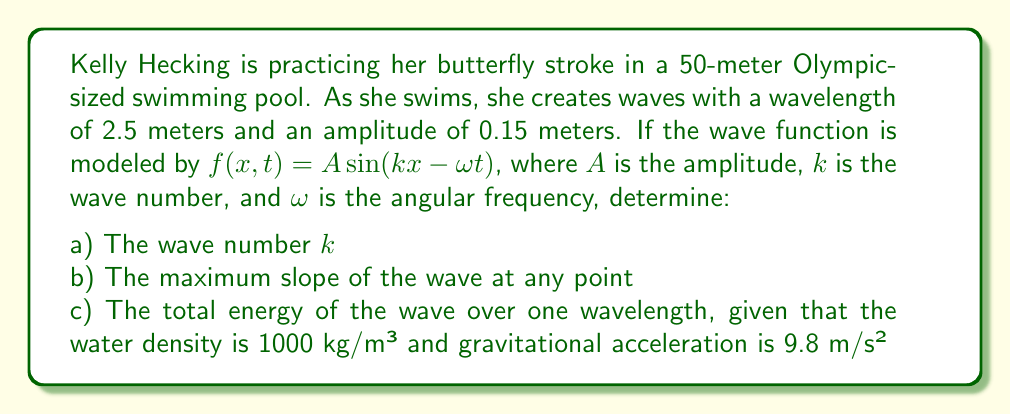Can you answer this question? Let's break this down step by step:

a) The wave number $k$ is related to the wavelength $\lambda$ by the equation:

   $$k = \frac{2\pi}{\lambda}$$

   Substituting $\lambda = 2.5$ m:

   $$k = \frac{2\pi}{2.5} = 2.51327 \text{ rad/m}$$

b) The slope of the wave at any point is given by the partial derivative of $f$ with respect to $x$:

   $$\frac{\partial f}{\partial x} = Ak \cos(kx - \omega t)$$

   The maximum slope occurs when $\cos(kx - \omega t) = \pm 1$, so:

   $$\text{Max slope} = |Ak| = 0.15 \cdot 2.51327 = 0.37699 \text{ or about } 0.377$$

c) The total energy of a wave over one wavelength is the sum of its kinetic and potential energies. For a sinusoidal wave, the average energy density is given by:

   $$E = \frac{1}{2}\rho g A^2$$

   where $\rho$ is the water density, $g$ is gravitational acceleration, and $A$ is the amplitude.

   The total energy over one wavelength is this energy density multiplied by the wavelength:

   $$E_{total} = \frac{1}{2}\rho g A^2 \lambda$$

   Substituting the values:

   $$E_{total} = \frac{1}{2} \cdot 1000 \cdot 9.8 \cdot (0.15)^2 \cdot 2.5$$
   
   $$E_{total} = 275.625 \text{ J}$$
Answer: a) $k = 2.51327 \text{ rad/m}$
b) Maximum slope = 0.377
c) $E_{total} = 275.625 \text{ J}$ 